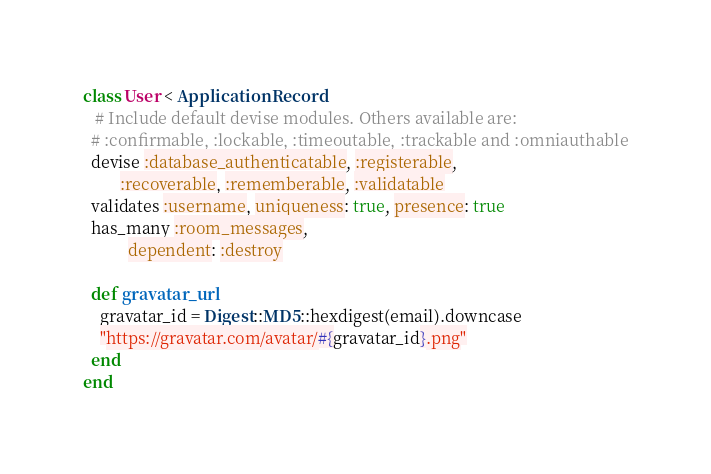Convert code to text. <code><loc_0><loc_0><loc_500><loc_500><_Ruby_>class User < ApplicationRecord
   # Include default devise modules. Others available are:
  # :confirmable, :lockable, :timeoutable, :trackable and :omniauthable
  devise :database_authenticatable, :registerable,
         :recoverable, :rememberable, :validatable
  validates :username, uniqueness: true, presence: true
  has_many :room_messages,
           dependent: :destroy

  def gravatar_url
    gravatar_id = Digest::MD5::hexdigest(email).downcase
    "https://gravatar.com/avatar/#{gravatar_id}.png"
  end
end
</code> 